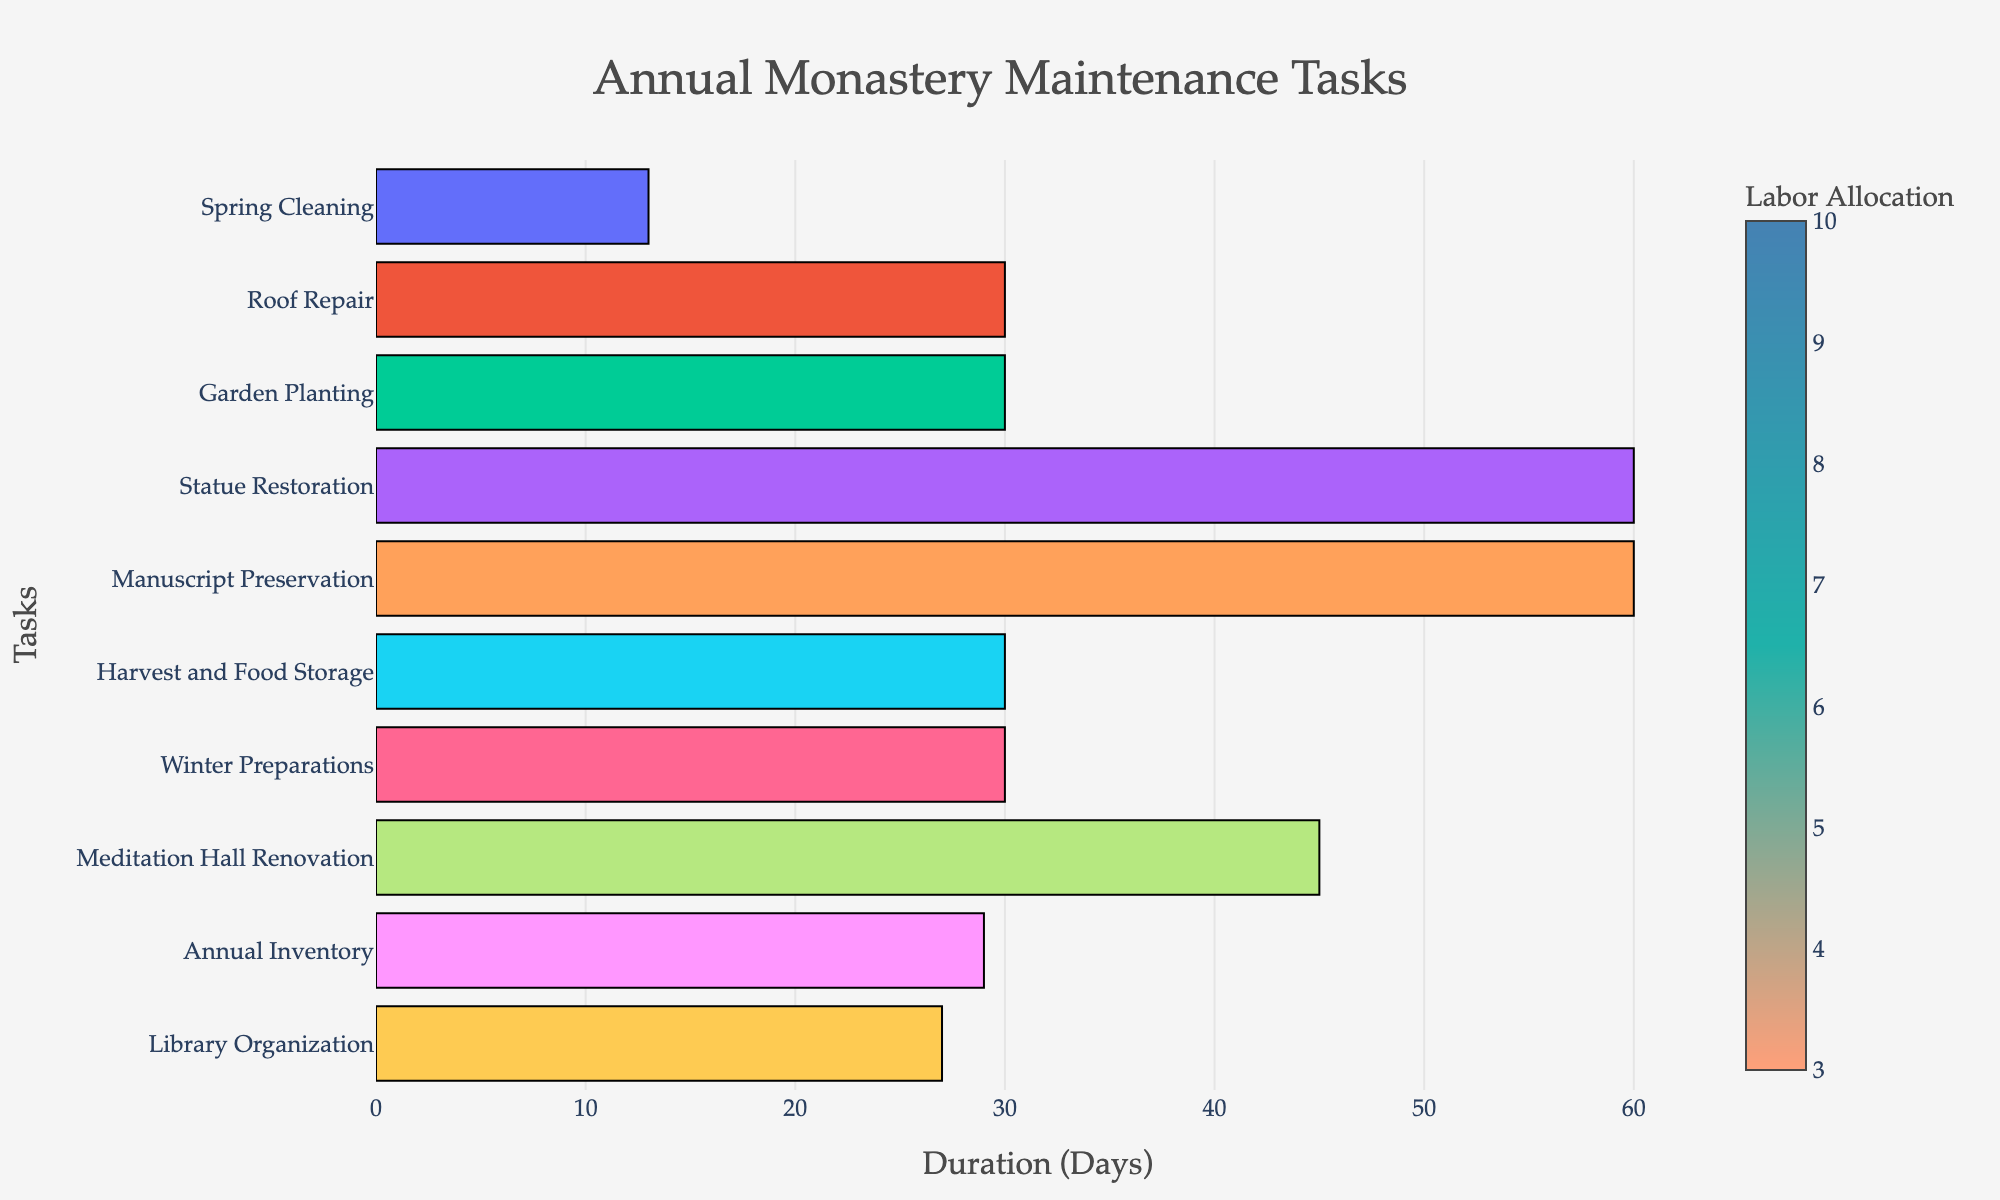What is the title of the Gantt Chart? The title of the chart is usually located at the top and is the first element one notices.
Answer: Annual Monastery Maintenance Tasks Which task has the highest labor allocation? By examining the color scale and its legend, we can compare the colors. The darkest bar has the highest labor allocation.
Answer: Harvest and Food Storage What is the duration of the Meditation Hall Renovation task? The horizontal length of the bar correlates with its duration. Checking the start and end date gives us the duration in days.
Answer: 46 days Which task spans the longest duration? By comparing the lengths of all horizontal bars, the longest one represents the task with the longest duration.
Answer: Statue Restoration How many tasks are scheduled during the summer season (June-August)? Summer includes June, July, and August. We look for tasks with dates overlapping this period.
Answer: Three tasks: Statue Restoration, Manuscript Preservation Comparing Garden Planting and Library Organization, which one requires more labor allocation? We identify the respective bars and compare their colors based on the color scale legend.
Answer: Garden Planting Which task starts immediately after Winter Preparations ends? Check the tasks’ timelines to see which starts on the day or soon after Winter Preparations concludes.
Answer: Meditation Hall Renovation What is the average labor allocation across all tasks? Sum the labor allocations of all tasks and divide by the number of tasks.
Answer: 5.8 monks What is the difference in labor allocation between Spring Cleaning and Annual Inventory? Subtract the labor allocation of Annual Inventory from Spring Cleaning.
Answer: 4 monks How many tasks overlap with parts of the Autumn season (September-November)? Autumn spans September to November, so determine which tasks’ durations overlap with these months.
Answer: Four tasks: Manuscript Preservation, Harvest and Food Storage, Winter Preparations, Meditation Hall Renovation 